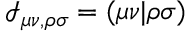Convert formula to latex. <formula><loc_0><loc_0><loc_500><loc_500>\mathcal { I } _ { \mu \nu , \rho \sigma } = ( \mu \nu | \rho \sigma )</formula> 